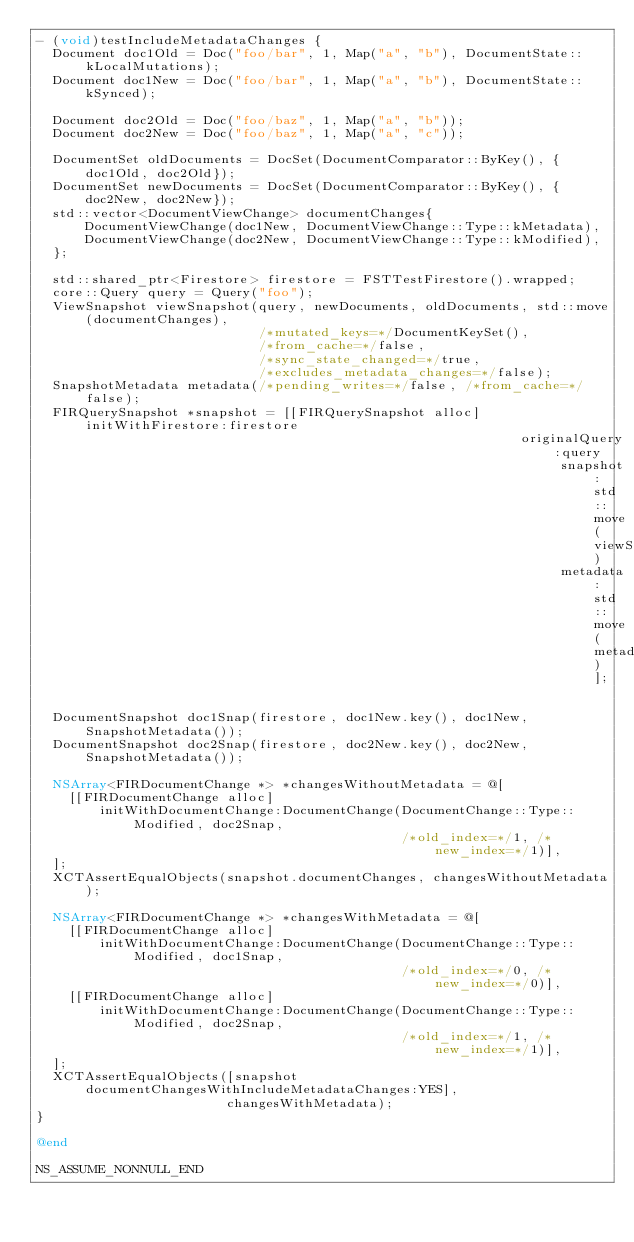Convert code to text. <code><loc_0><loc_0><loc_500><loc_500><_ObjectiveC_>- (void)testIncludeMetadataChanges {
  Document doc1Old = Doc("foo/bar", 1, Map("a", "b"), DocumentState::kLocalMutations);
  Document doc1New = Doc("foo/bar", 1, Map("a", "b"), DocumentState::kSynced);

  Document doc2Old = Doc("foo/baz", 1, Map("a", "b"));
  Document doc2New = Doc("foo/baz", 1, Map("a", "c"));

  DocumentSet oldDocuments = DocSet(DocumentComparator::ByKey(), {doc1Old, doc2Old});
  DocumentSet newDocuments = DocSet(DocumentComparator::ByKey(), {doc2New, doc2New});
  std::vector<DocumentViewChange> documentChanges{
      DocumentViewChange(doc1New, DocumentViewChange::Type::kMetadata),
      DocumentViewChange(doc2New, DocumentViewChange::Type::kModified),
  };

  std::shared_ptr<Firestore> firestore = FSTTestFirestore().wrapped;
  core::Query query = Query("foo");
  ViewSnapshot viewSnapshot(query, newDocuments, oldDocuments, std::move(documentChanges),
                            /*mutated_keys=*/DocumentKeySet(),
                            /*from_cache=*/false,
                            /*sync_state_changed=*/true,
                            /*excludes_metadata_changes=*/false);
  SnapshotMetadata metadata(/*pending_writes=*/false, /*from_cache=*/false);
  FIRQuerySnapshot *snapshot = [[FIRQuerySnapshot alloc] initWithFirestore:firestore
                                                             originalQuery:query
                                                                  snapshot:std::move(viewSnapshot)
                                                                  metadata:std::move(metadata)];

  DocumentSnapshot doc1Snap(firestore, doc1New.key(), doc1New, SnapshotMetadata());
  DocumentSnapshot doc2Snap(firestore, doc2New.key(), doc2New, SnapshotMetadata());

  NSArray<FIRDocumentChange *> *changesWithoutMetadata = @[
    [[FIRDocumentChange alloc]
        initWithDocumentChange:DocumentChange(DocumentChange::Type::Modified, doc2Snap,
                                              /*old_index=*/1, /*new_index=*/1)],
  ];
  XCTAssertEqualObjects(snapshot.documentChanges, changesWithoutMetadata);

  NSArray<FIRDocumentChange *> *changesWithMetadata = @[
    [[FIRDocumentChange alloc]
        initWithDocumentChange:DocumentChange(DocumentChange::Type::Modified, doc1Snap,
                                              /*old_index=*/0, /*new_index=*/0)],
    [[FIRDocumentChange alloc]
        initWithDocumentChange:DocumentChange(DocumentChange::Type::Modified, doc2Snap,
                                              /*old_index=*/1, /*new_index=*/1)],
  ];
  XCTAssertEqualObjects([snapshot documentChangesWithIncludeMetadataChanges:YES],
                        changesWithMetadata);
}

@end

NS_ASSUME_NONNULL_END
</code> 